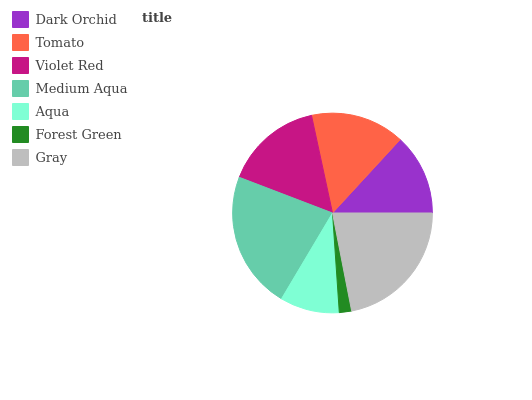Is Forest Green the minimum?
Answer yes or no. Yes. Is Medium Aqua the maximum?
Answer yes or no. Yes. Is Tomato the minimum?
Answer yes or no. No. Is Tomato the maximum?
Answer yes or no. No. Is Tomato greater than Dark Orchid?
Answer yes or no. Yes. Is Dark Orchid less than Tomato?
Answer yes or no. Yes. Is Dark Orchid greater than Tomato?
Answer yes or no. No. Is Tomato less than Dark Orchid?
Answer yes or no. No. Is Tomato the high median?
Answer yes or no. Yes. Is Tomato the low median?
Answer yes or no. Yes. Is Aqua the high median?
Answer yes or no. No. Is Dark Orchid the low median?
Answer yes or no. No. 